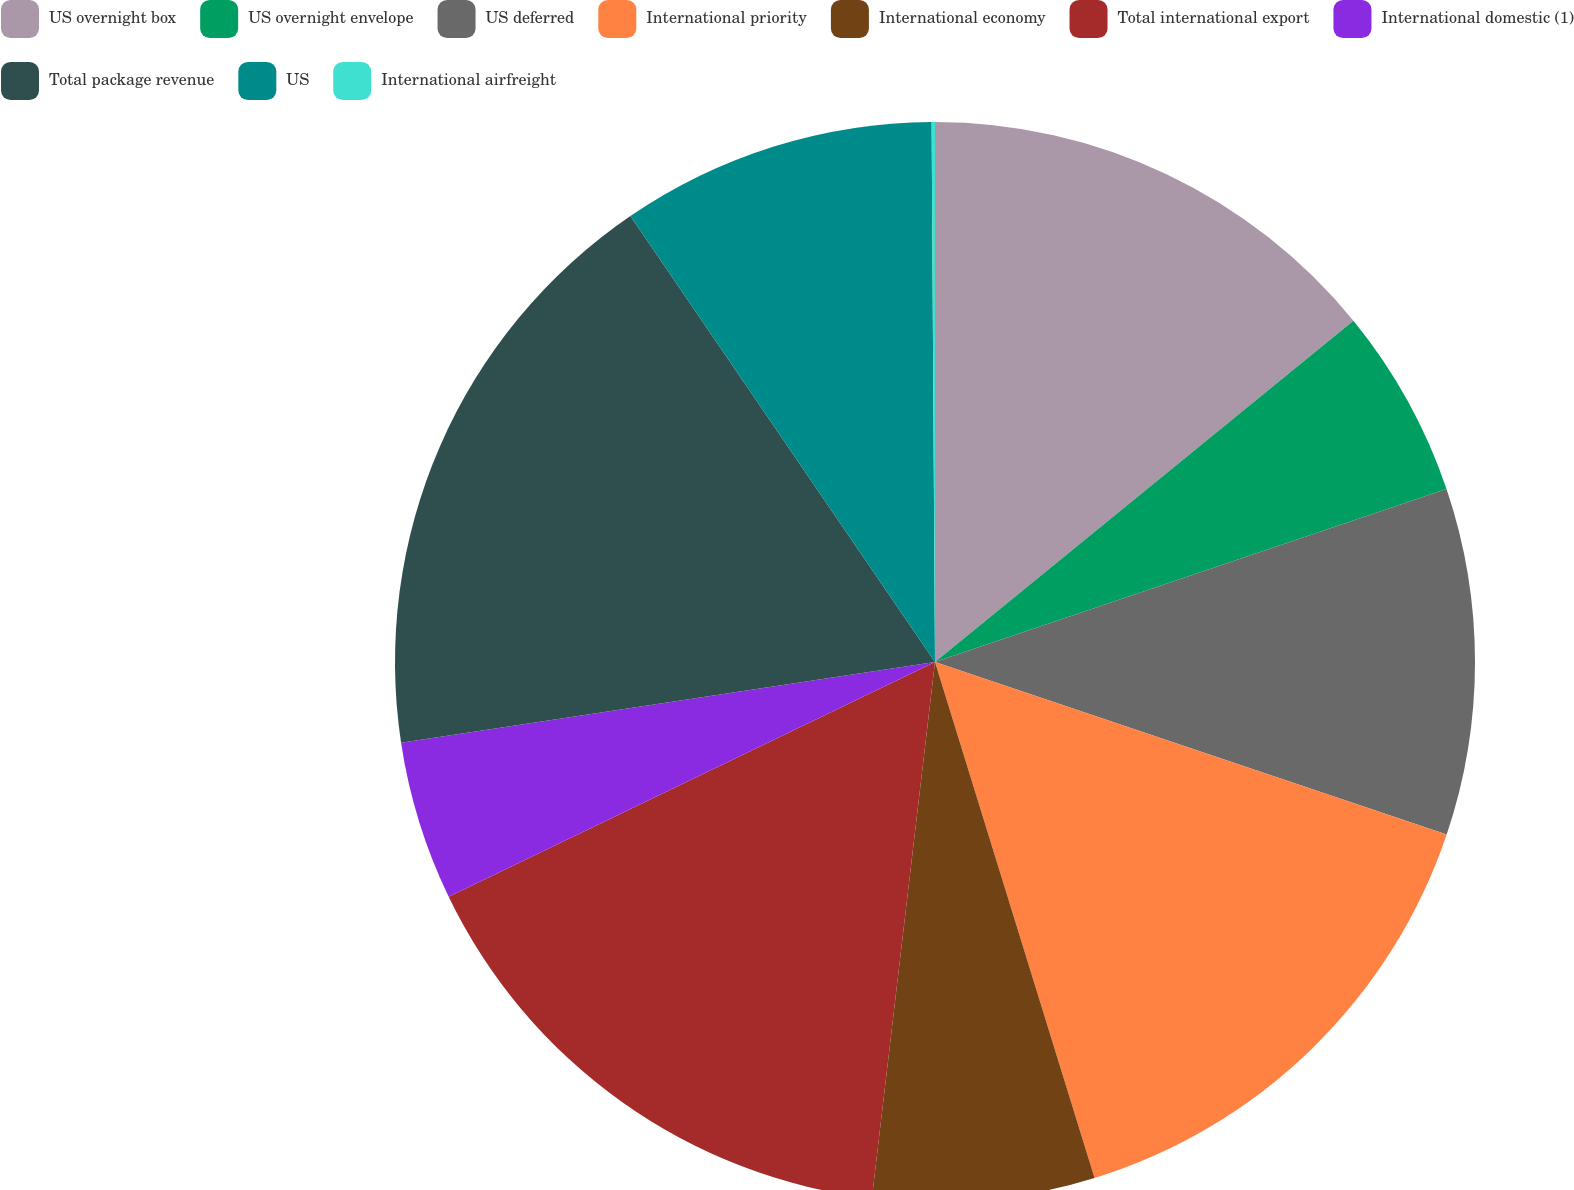Convert chart to OTSL. <chart><loc_0><loc_0><loc_500><loc_500><pie_chart><fcel>US overnight box<fcel>US overnight envelope<fcel>US deferred<fcel>International priority<fcel>International economy<fcel>Total international export<fcel>International domestic (1)<fcel>Total package revenue<fcel>US<fcel>International airfreight<nl><fcel>14.11%<fcel>5.7%<fcel>10.37%<fcel>15.05%<fcel>6.64%<fcel>15.98%<fcel>4.77%<fcel>17.85%<fcel>9.44%<fcel>0.1%<nl></chart> 